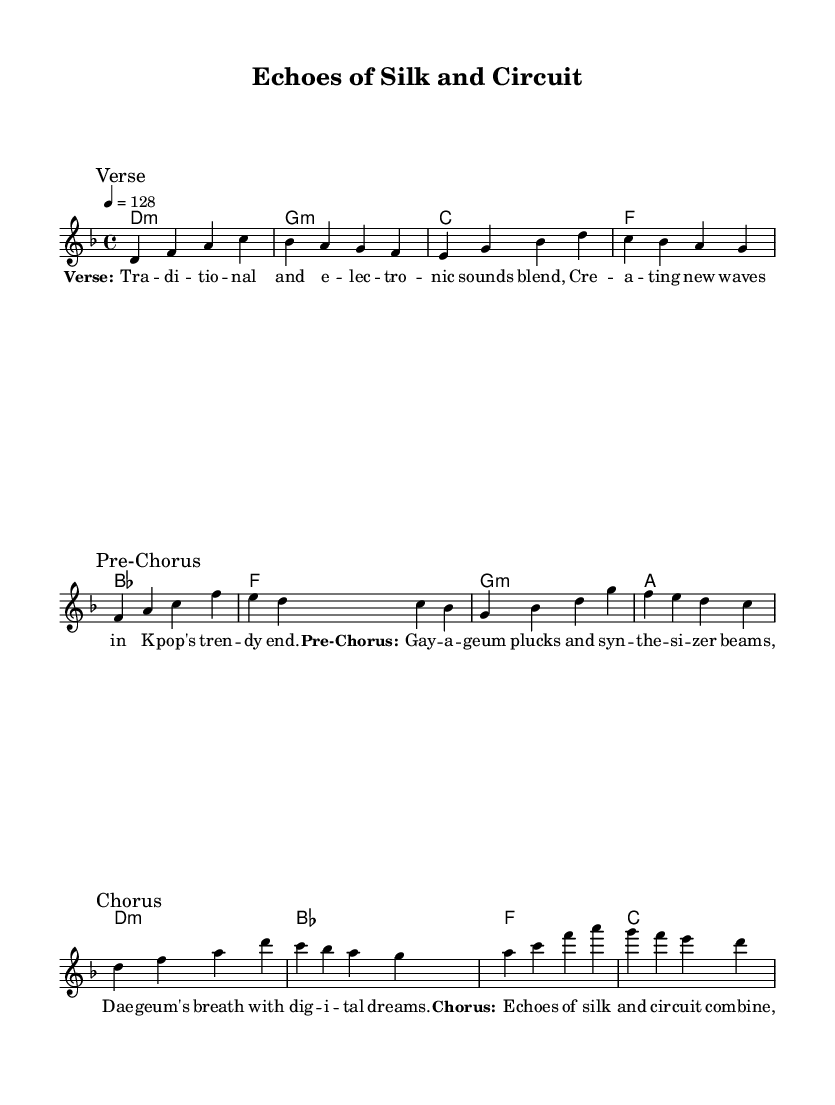What is the key signature of this music? The key signature is indicated by the key at the beginning of the music, which shows two flats (B♭ and E♭), characteristic of D minor.
Answer: D minor What is the time signature of the piece? The time signature is located at the beginning of the music, represented by the "4/4," which means there are four beats in each measure and the quarter note gets one beat.
Answer: 4/4 What is the tempo marking for the song? The tempo is specified at the beginning with "4 = 128," indicating that there are 128 beats per minute, meaning it's a moderately fast tempo generally suitable for pop music.
Answer: 128 How many measures are in the verse section? By counting the measures from the melody section marked "Verse," there are four measures in total.
Answer: 4 Which traditional instrument is referenced in the lyrics? The lyrics mention the "Gayageum," a traditional Korean string instrument, highlighting the blend of traditional and electronic sounds in the piece.
Answer: Gayageum What is the form of this composition in terms of structure? Analyzing the labeled sections, the form progresses through the Verse, Pre-Chorus, and Chorus, indicating a standard verse-chorus structure common in K-Pop music.
Answer: Verse, Pre-Chorus, Chorus 